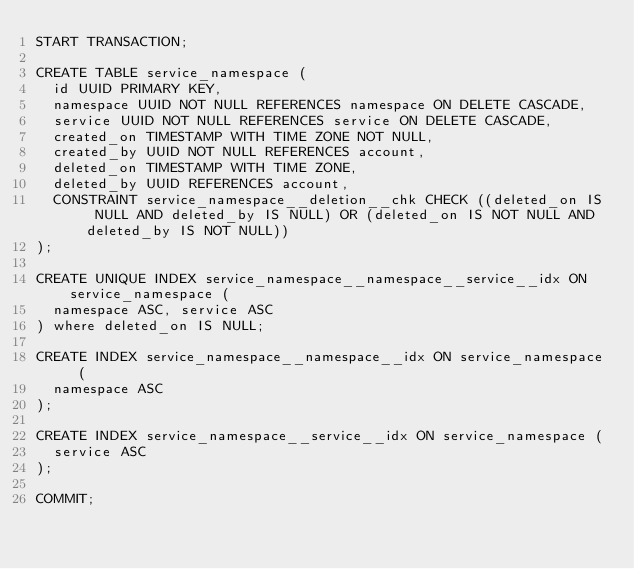Convert code to text. <code><loc_0><loc_0><loc_500><loc_500><_SQL_>START TRANSACTION;

CREATE TABLE service_namespace (
  id UUID PRIMARY KEY,
  namespace UUID NOT NULL REFERENCES namespace ON DELETE CASCADE,
  service UUID NOT NULL REFERENCES service ON DELETE CASCADE,
  created_on TIMESTAMP WITH TIME ZONE NOT NULL,
  created_by UUID NOT NULL REFERENCES account,
  deleted_on TIMESTAMP WITH TIME ZONE,
  deleted_by UUID REFERENCES account,
  CONSTRAINT service_namespace__deletion__chk CHECK ((deleted_on IS NULL AND deleted_by IS NULL) OR (deleted_on IS NOT NULL AND deleted_by IS NOT NULL))
);

CREATE UNIQUE INDEX service_namespace__namespace__service__idx ON service_namespace (
  namespace ASC, service ASC
) where deleted_on IS NULL;

CREATE INDEX service_namespace__namespace__idx ON service_namespace (
  namespace ASC
);

CREATE INDEX service_namespace__service__idx ON service_namespace (
  service ASC
);

COMMIT;
</code> 